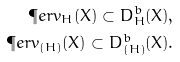Convert formula to latex. <formula><loc_0><loc_0><loc_500><loc_500>\P e r v _ { H } ( X ) \subset D ^ { b } _ { H } ( X ) , \\ \P e r v _ { ( H ) } ( X ) \subset D ^ { b } _ { ( H ) } ( X ) .</formula> 